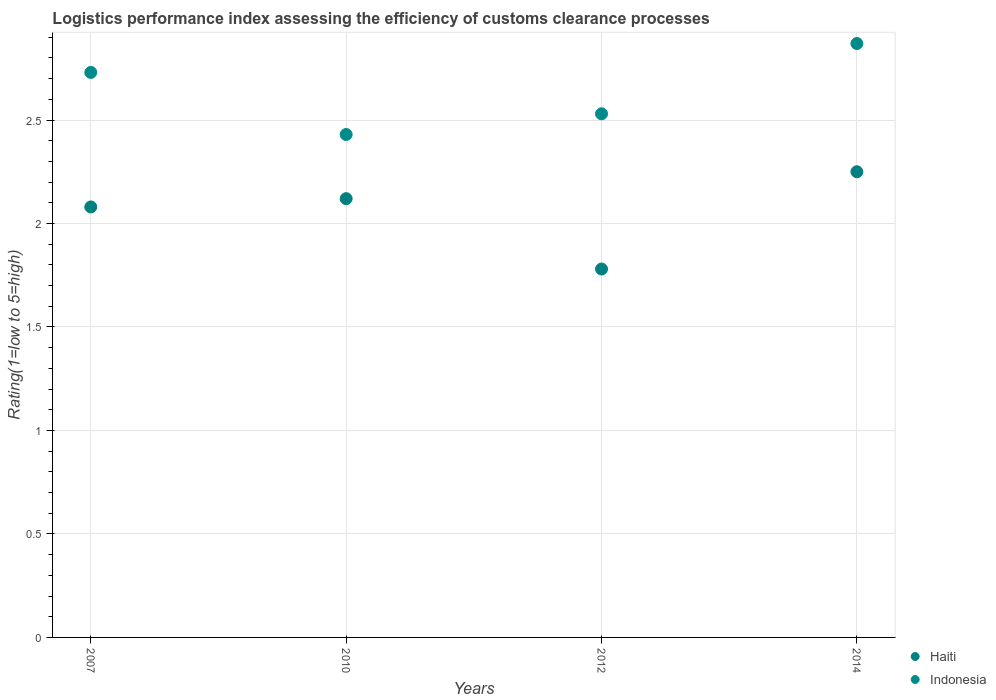Is the number of dotlines equal to the number of legend labels?
Provide a succinct answer. Yes. What is the Logistic performance index in Haiti in 2010?
Give a very brief answer. 2.12. Across all years, what is the maximum Logistic performance index in Haiti?
Offer a terse response. 2.25. Across all years, what is the minimum Logistic performance index in Indonesia?
Ensure brevity in your answer.  2.43. In which year was the Logistic performance index in Haiti maximum?
Offer a very short reply. 2014. What is the total Logistic performance index in Indonesia in the graph?
Offer a very short reply. 10.56. What is the difference between the Logistic performance index in Indonesia in 2007 and that in 2014?
Your response must be concise. -0.14. What is the difference between the Logistic performance index in Haiti in 2014 and the Logistic performance index in Indonesia in 2012?
Provide a short and direct response. -0.28. What is the average Logistic performance index in Haiti per year?
Offer a terse response. 2.06. In the year 2007, what is the difference between the Logistic performance index in Haiti and Logistic performance index in Indonesia?
Give a very brief answer. -0.65. In how many years, is the Logistic performance index in Indonesia greater than 1.2?
Offer a terse response. 4. What is the ratio of the Logistic performance index in Indonesia in 2010 to that in 2012?
Your response must be concise. 0.96. Is the difference between the Logistic performance index in Haiti in 2007 and 2014 greater than the difference between the Logistic performance index in Indonesia in 2007 and 2014?
Your response must be concise. No. What is the difference between the highest and the second highest Logistic performance index in Indonesia?
Provide a succinct answer. 0.14. What is the difference between the highest and the lowest Logistic performance index in Haiti?
Make the answer very short. 0.47. Does the Logistic performance index in Haiti monotonically increase over the years?
Offer a terse response. No. Is the Logistic performance index in Haiti strictly greater than the Logistic performance index in Indonesia over the years?
Ensure brevity in your answer.  No. Does the graph contain grids?
Your response must be concise. Yes. Where does the legend appear in the graph?
Keep it short and to the point. Bottom right. How many legend labels are there?
Your answer should be very brief. 2. What is the title of the graph?
Offer a terse response. Logistics performance index assessing the efficiency of customs clearance processes. What is the label or title of the Y-axis?
Give a very brief answer. Rating(1=low to 5=high). What is the Rating(1=low to 5=high) of Haiti in 2007?
Your response must be concise. 2.08. What is the Rating(1=low to 5=high) in Indonesia in 2007?
Provide a succinct answer. 2.73. What is the Rating(1=low to 5=high) of Haiti in 2010?
Make the answer very short. 2.12. What is the Rating(1=low to 5=high) in Indonesia in 2010?
Make the answer very short. 2.43. What is the Rating(1=low to 5=high) in Haiti in 2012?
Your answer should be compact. 1.78. What is the Rating(1=low to 5=high) in Indonesia in 2012?
Your response must be concise. 2.53. What is the Rating(1=low to 5=high) in Haiti in 2014?
Ensure brevity in your answer.  2.25. What is the Rating(1=low to 5=high) of Indonesia in 2014?
Give a very brief answer. 2.87. Across all years, what is the maximum Rating(1=low to 5=high) in Haiti?
Offer a terse response. 2.25. Across all years, what is the maximum Rating(1=low to 5=high) of Indonesia?
Give a very brief answer. 2.87. Across all years, what is the minimum Rating(1=low to 5=high) in Haiti?
Make the answer very short. 1.78. Across all years, what is the minimum Rating(1=low to 5=high) in Indonesia?
Your answer should be very brief. 2.43. What is the total Rating(1=low to 5=high) in Haiti in the graph?
Make the answer very short. 8.23. What is the total Rating(1=low to 5=high) in Indonesia in the graph?
Make the answer very short. 10.56. What is the difference between the Rating(1=low to 5=high) in Haiti in 2007 and that in 2010?
Provide a short and direct response. -0.04. What is the difference between the Rating(1=low to 5=high) of Indonesia in 2007 and that in 2010?
Your answer should be compact. 0.3. What is the difference between the Rating(1=low to 5=high) of Haiti in 2007 and that in 2014?
Offer a very short reply. -0.17. What is the difference between the Rating(1=low to 5=high) in Indonesia in 2007 and that in 2014?
Offer a very short reply. -0.14. What is the difference between the Rating(1=low to 5=high) in Haiti in 2010 and that in 2012?
Give a very brief answer. 0.34. What is the difference between the Rating(1=low to 5=high) of Haiti in 2010 and that in 2014?
Your answer should be very brief. -0.13. What is the difference between the Rating(1=low to 5=high) in Indonesia in 2010 and that in 2014?
Give a very brief answer. -0.44. What is the difference between the Rating(1=low to 5=high) of Haiti in 2012 and that in 2014?
Offer a terse response. -0.47. What is the difference between the Rating(1=low to 5=high) of Indonesia in 2012 and that in 2014?
Provide a short and direct response. -0.34. What is the difference between the Rating(1=low to 5=high) in Haiti in 2007 and the Rating(1=low to 5=high) in Indonesia in 2010?
Your answer should be compact. -0.35. What is the difference between the Rating(1=low to 5=high) in Haiti in 2007 and the Rating(1=low to 5=high) in Indonesia in 2012?
Provide a short and direct response. -0.45. What is the difference between the Rating(1=low to 5=high) of Haiti in 2007 and the Rating(1=low to 5=high) of Indonesia in 2014?
Provide a succinct answer. -0.79. What is the difference between the Rating(1=low to 5=high) of Haiti in 2010 and the Rating(1=low to 5=high) of Indonesia in 2012?
Ensure brevity in your answer.  -0.41. What is the difference between the Rating(1=low to 5=high) in Haiti in 2010 and the Rating(1=low to 5=high) in Indonesia in 2014?
Offer a terse response. -0.75. What is the difference between the Rating(1=low to 5=high) of Haiti in 2012 and the Rating(1=low to 5=high) of Indonesia in 2014?
Keep it short and to the point. -1.09. What is the average Rating(1=low to 5=high) in Haiti per year?
Your answer should be very brief. 2.06. What is the average Rating(1=low to 5=high) in Indonesia per year?
Give a very brief answer. 2.64. In the year 2007, what is the difference between the Rating(1=low to 5=high) in Haiti and Rating(1=low to 5=high) in Indonesia?
Your response must be concise. -0.65. In the year 2010, what is the difference between the Rating(1=low to 5=high) of Haiti and Rating(1=low to 5=high) of Indonesia?
Offer a very short reply. -0.31. In the year 2012, what is the difference between the Rating(1=low to 5=high) in Haiti and Rating(1=low to 5=high) in Indonesia?
Your answer should be very brief. -0.75. In the year 2014, what is the difference between the Rating(1=low to 5=high) of Haiti and Rating(1=low to 5=high) of Indonesia?
Provide a succinct answer. -0.62. What is the ratio of the Rating(1=low to 5=high) of Haiti in 2007 to that in 2010?
Keep it short and to the point. 0.98. What is the ratio of the Rating(1=low to 5=high) in Indonesia in 2007 to that in 2010?
Offer a terse response. 1.12. What is the ratio of the Rating(1=low to 5=high) in Haiti in 2007 to that in 2012?
Your response must be concise. 1.17. What is the ratio of the Rating(1=low to 5=high) of Indonesia in 2007 to that in 2012?
Provide a succinct answer. 1.08. What is the ratio of the Rating(1=low to 5=high) in Haiti in 2007 to that in 2014?
Offer a very short reply. 0.92. What is the ratio of the Rating(1=low to 5=high) in Indonesia in 2007 to that in 2014?
Make the answer very short. 0.95. What is the ratio of the Rating(1=low to 5=high) in Haiti in 2010 to that in 2012?
Offer a terse response. 1.19. What is the ratio of the Rating(1=low to 5=high) in Indonesia in 2010 to that in 2012?
Your answer should be very brief. 0.96. What is the ratio of the Rating(1=low to 5=high) of Haiti in 2010 to that in 2014?
Your response must be concise. 0.94. What is the ratio of the Rating(1=low to 5=high) in Indonesia in 2010 to that in 2014?
Your response must be concise. 0.85. What is the ratio of the Rating(1=low to 5=high) in Haiti in 2012 to that in 2014?
Provide a succinct answer. 0.79. What is the ratio of the Rating(1=low to 5=high) of Indonesia in 2012 to that in 2014?
Provide a succinct answer. 0.88. What is the difference between the highest and the second highest Rating(1=low to 5=high) in Haiti?
Ensure brevity in your answer.  0.13. What is the difference between the highest and the second highest Rating(1=low to 5=high) of Indonesia?
Provide a succinct answer. 0.14. What is the difference between the highest and the lowest Rating(1=low to 5=high) of Haiti?
Provide a short and direct response. 0.47. What is the difference between the highest and the lowest Rating(1=low to 5=high) of Indonesia?
Ensure brevity in your answer.  0.44. 